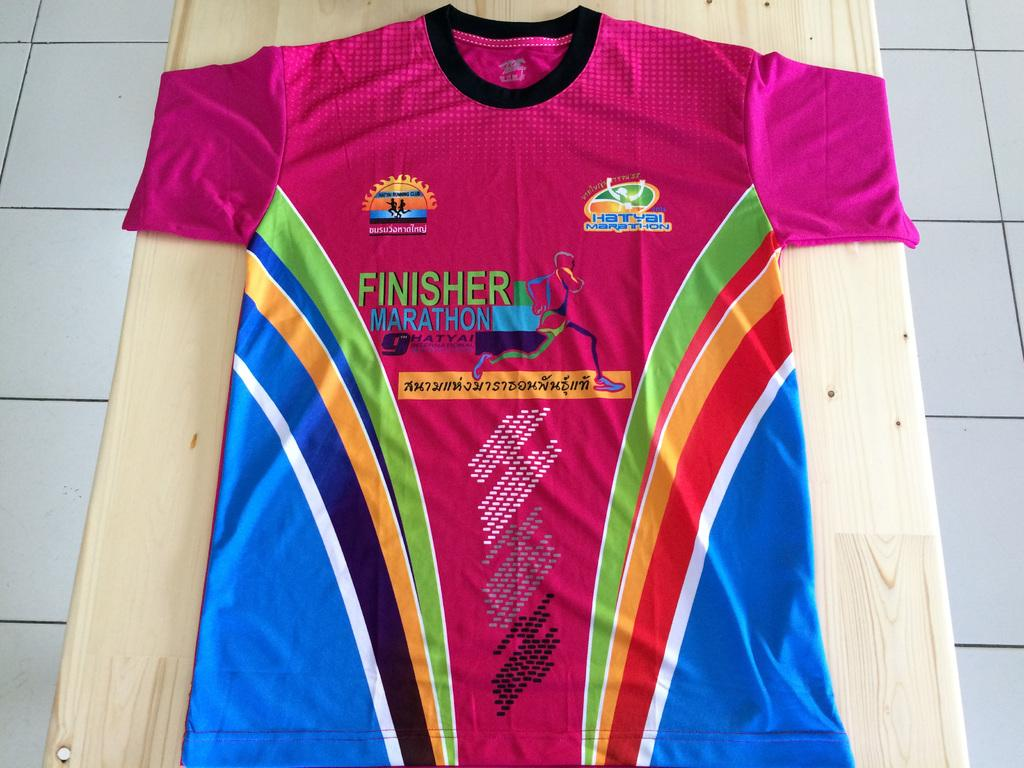<image>
Give a short and clear explanation of the subsequent image. a shirt that has the word finisher on it 